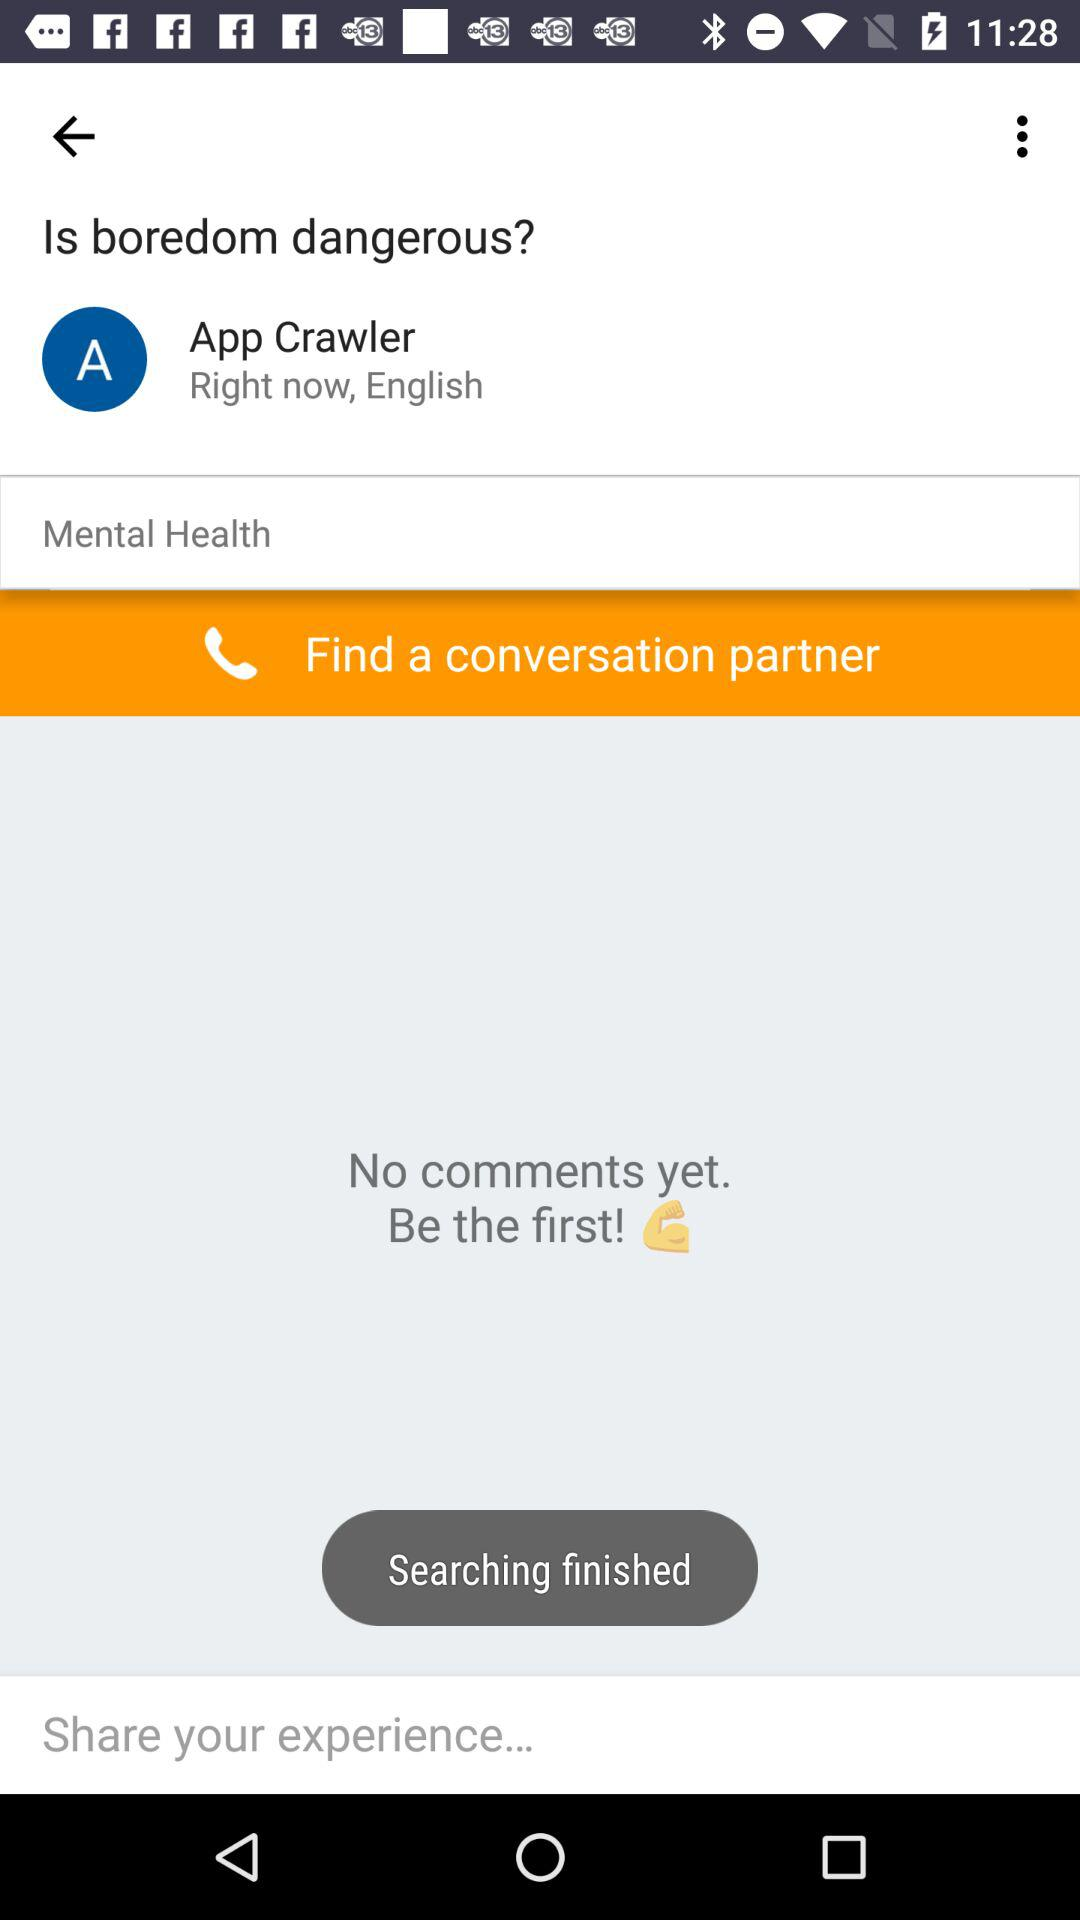Are there any comments? There are no comments. 